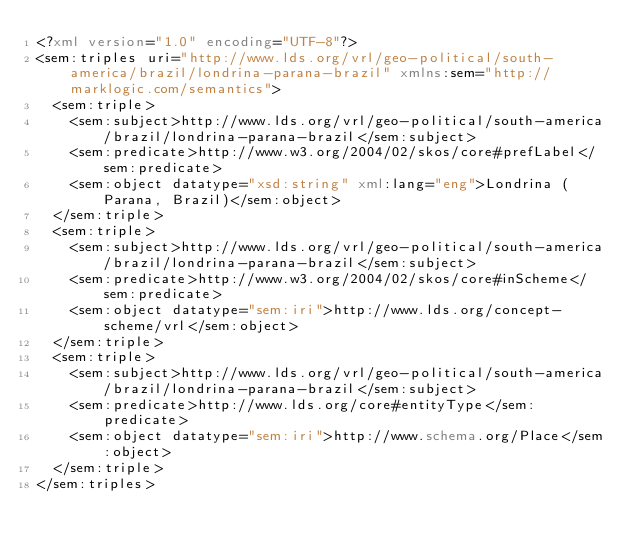Convert code to text. <code><loc_0><loc_0><loc_500><loc_500><_XML_><?xml version="1.0" encoding="UTF-8"?>
<sem:triples uri="http://www.lds.org/vrl/geo-political/south-america/brazil/londrina-parana-brazil" xmlns:sem="http://marklogic.com/semantics">
  <sem:triple>
    <sem:subject>http://www.lds.org/vrl/geo-political/south-america/brazil/londrina-parana-brazil</sem:subject>
    <sem:predicate>http://www.w3.org/2004/02/skos/core#prefLabel</sem:predicate>
    <sem:object datatype="xsd:string" xml:lang="eng">Londrina (Parana, Brazil)</sem:object>
  </sem:triple>
  <sem:triple>
    <sem:subject>http://www.lds.org/vrl/geo-political/south-america/brazil/londrina-parana-brazil</sem:subject>
    <sem:predicate>http://www.w3.org/2004/02/skos/core#inScheme</sem:predicate>
    <sem:object datatype="sem:iri">http://www.lds.org/concept-scheme/vrl</sem:object>
  </sem:triple>
  <sem:triple>
    <sem:subject>http://www.lds.org/vrl/geo-political/south-america/brazil/londrina-parana-brazil</sem:subject>
    <sem:predicate>http://www.lds.org/core#entityType</sem:predicate>
    <sem:object datatype="sem:iri">http://www.schema.org/Place</sem:object>
  </sem:triple>
</sem:triples>
</code> 